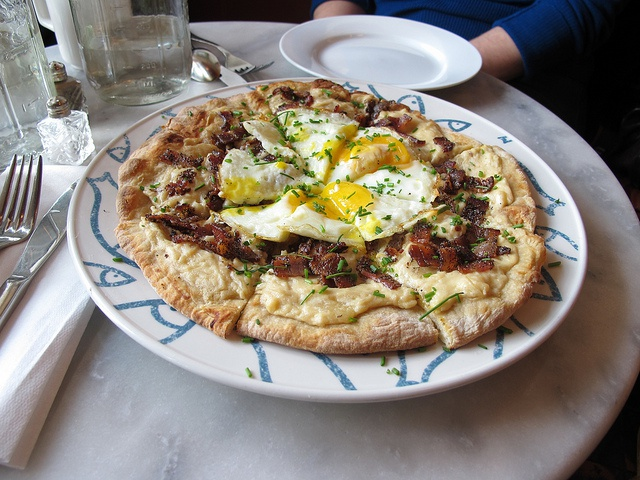Describe the objects in this image and their specific colors. I can see dining table in darkgray, gray, lightgray, and maroon tones, pizza in gray, tan, maroon, and ivory tones, cup in gray and black tones, people in gray, navy, black, and darkgray tones, and cup in gray, darkgray, and lightgray tones in this image. 